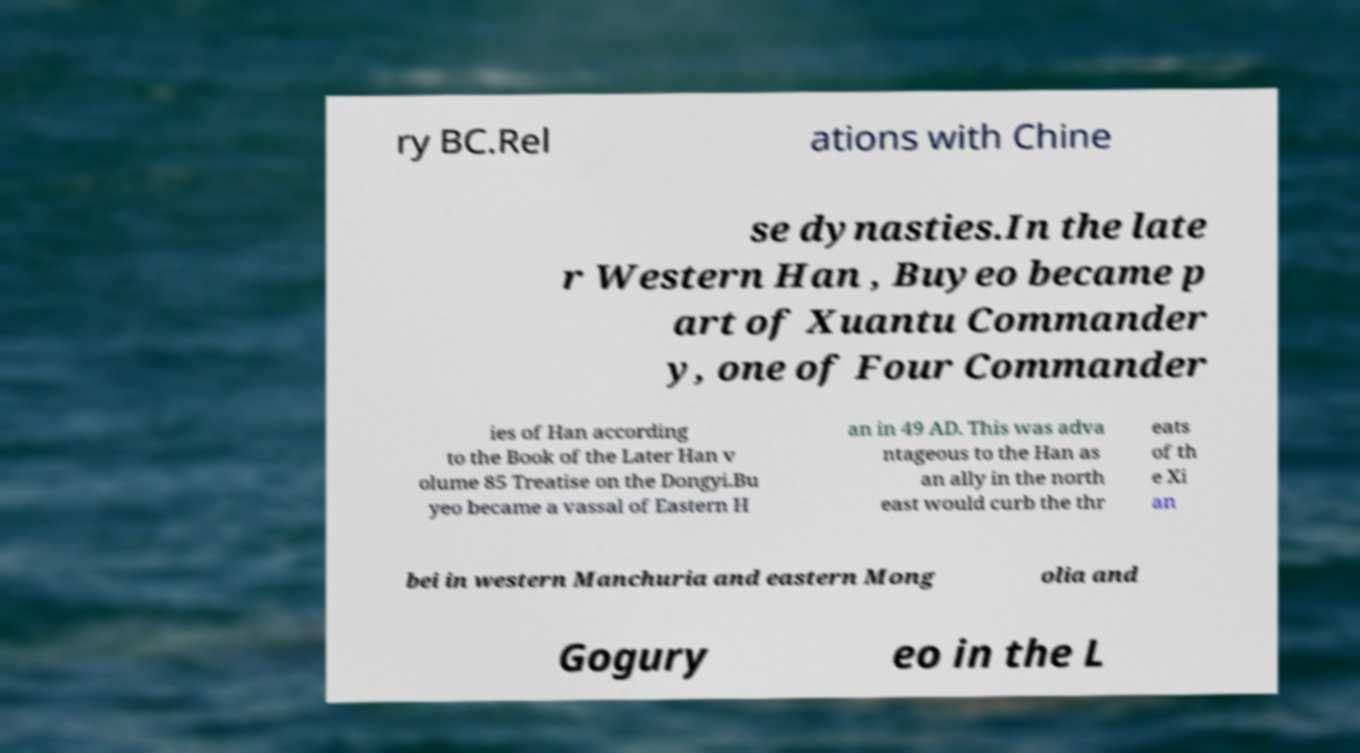There's text embedded in this image that I need extracted. Can you transcribe it verbatim? ry BC.Rel ations with Chine se dynasties.In the late r Western Han , Buyeo became p art of Xuantu Commander y, one of Four Commander ies of Han according to the Book of the Later Han v olume 85 Treatise on the Dongyi.Bu yeo became a vassal of Eastern H an in 49 AD. This was adva ntageous to the Han as an ally in the north east would curb the thr eats of th e Xi an bei in western Manchuria and eastern Mong olia and Gogury eo in the L 